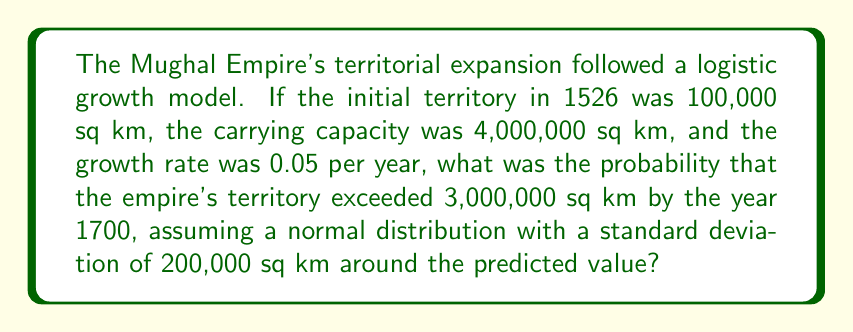Help me with this question. 1. First, we need to calculate the expected territory size in 1700 using the logistic growth model:

   $$P(t) = \frac{K}{1 + (\frac{K}{P_0} - 1)e^{-rt}}$$

   Where:
   $P(t)$ is the territory size at time $t$
   $K$ is the carrying capacity (4,000,000 sq km)
   $P_0$ is the initial territory (100,000 sq km)
   $r$ is the growth rate (0.05 per year)
   $t$ is the time elapsed (1700 - 1526 = 174 years)

2. Plugging in the values:

   $$P(174) = \frac{4,000,000}{1 + (\frac{4,000,000}{100,000} - 1)e^{-0.05 \cdot 174}}$$

3. Calculating:

   $$P(174) \approx 3,654,605 \text{ sq km}$$

4. Now, we need to find the z-score for 3,000,000 sq km:

   $$z = \frac{x - \mu}{\sigma} = \frac{3,000,000 - 3,654,605}{200,000} \approx -3.27$$

5. The probability that the territory exceeds 3,000,000 sq km is equal to the area under the standard normal curve to the right of z = -3.27.

6. Using a standard normal table or calculator, we find:

   $$P(Z > -3.27) = 1 - P(Z < -3.27) \approx 0.9995$$

Therefore, the probability that the empire's territory exceeded 3,000,000 sq km by 1700 is approximately 0.9995 or 99.95%.
Answer: 0.9995 